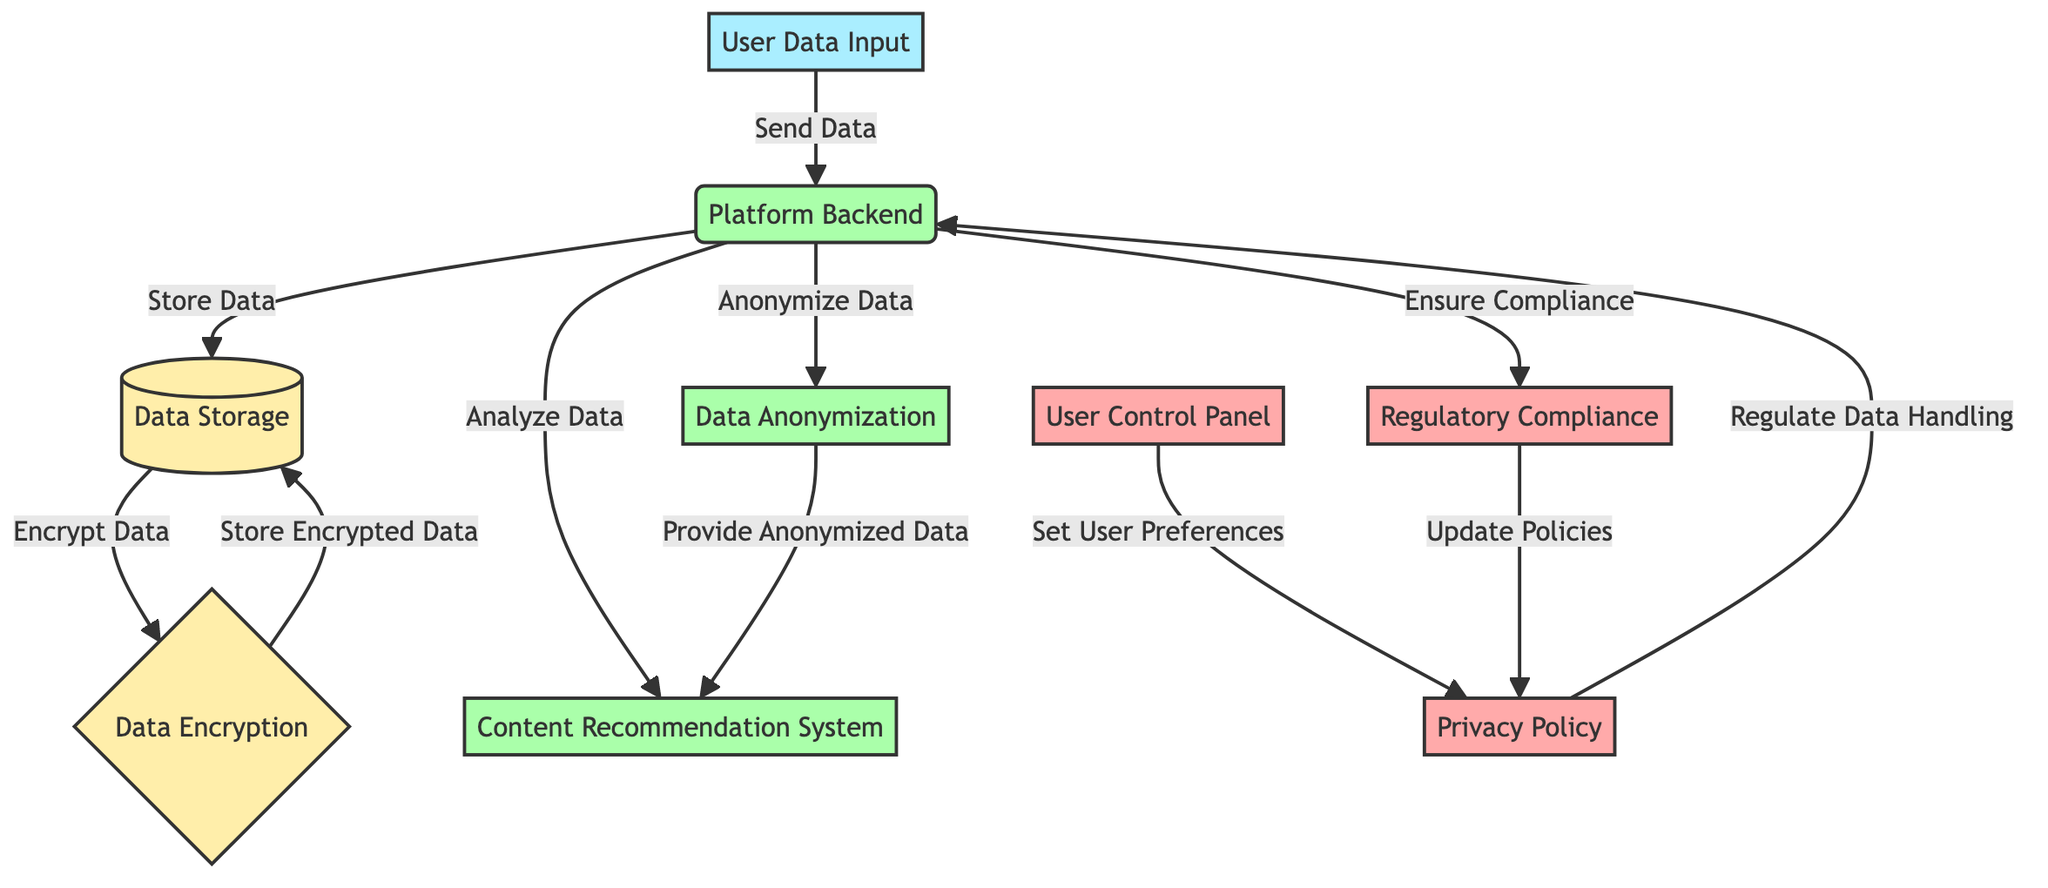What is the starting point of the user data flow? The diagram indicates that the flow begins with the "User Data Input" node, which shows that users first input their data before it moves to the platform backend.
Answer: User Data Input How many processes are involved in the data flow? By counting the nodes labeled as processes in the diagram, we identify "Platform Backend", "Content Recommendation System", "Data Anonymization", and "Regulatory Compliance". This totals to four processes.
Answer: Four What type of node is the "Data Storage"? The diagram clearly defines "Data Storage" as a storage node, as marked by its classification in the diagram.
Answer: Storage Which node regulates data handling? The "Privacy Policy" node governs the data handling in the diagram, as shown with an arrow pointing to the "Platform Backend", indicating regulation.
Answer: Privacy Policy What action occurs after data is sent to the "Platform Backend"? Once data is sent to the "Platform Backend", the immediate action is to "Store Data" in the "Data Storage". This sequence is illustrated clearly in the diagram flow.
Answer: Store Data What type of data handling is recommended by the "User Control Panel"? The "User Control Panel" allows users to "Set User Preferences", which directly influences how their data is handled according to the privacy policies outlined.
Answer: Set User Preferences Which node provides anonymized data to the recommendation system? The "Data Anonymization" node is responsible for supplying anonymized data to the "Content Recommendation System", as depicted by the directed arrow in the diagram.
Answer: Data Anonymization How does the diagram ensure user data compliance? The "Platform Backend" ensures compliance through the node "Regulatory Compliance", which then informs and updates the "Privacy Policy", demonstrating a direct relationship between compliance and policy adjustments.
Answer: Regulatory Compliance What happens to data after it is encrypted? After data is encrypted, it is stored again within the "Data Storage" node, indicating that encrypted data also needs to be securely kept.
Answer: Store Encrypted Data 